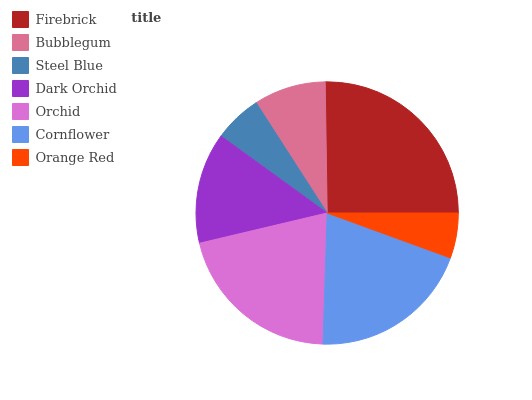Is Orange Red the minimum?
Answer yes or no. Yes. Is Firebrick the maximum?
Answer yes or no. Yes. Is Bubblegum the minimum?
Answer yes or no. No. Is Bubblegum the maximum?
Answer yes or no. No. Is Firebrick greater than Bubblegum?
Answer yes or no. Yes. Is Bubblegum less than Firebrick?
Answer yes or no. Yes. Is Bubblegum greater than Firebrick?
Answer yes or no. No. Is Firebrick less than Bubblegum?
Answer yes or no. No. Is Dark Orchid the high median?
Answer yes or no. Yes. Is Dark Orchid the low median?
Answer yes or no. Yes. Is Firebrick the high median?
Answer yes or no. No. Is Bubblegum the low median?
Answer yes or no. No. 